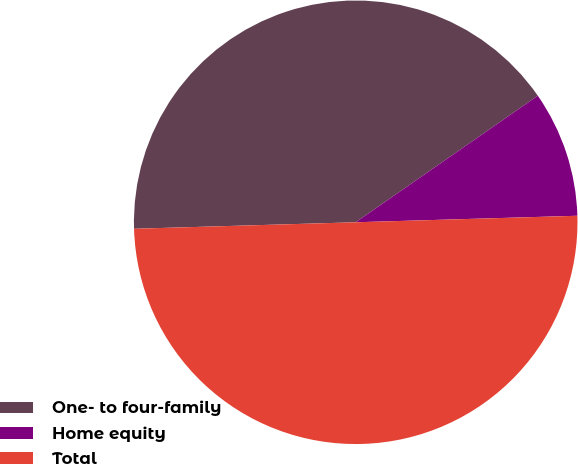Convert chart to OTSL. <chart><loc_0><loc_0><loc_500><loc_500><pie_chart><fcel>One- to four-family<fcel>Home equity<fcel>Total<nl><fcel>40.8%<fcel>9.2%<fcel>50.0%<nl></chart> 